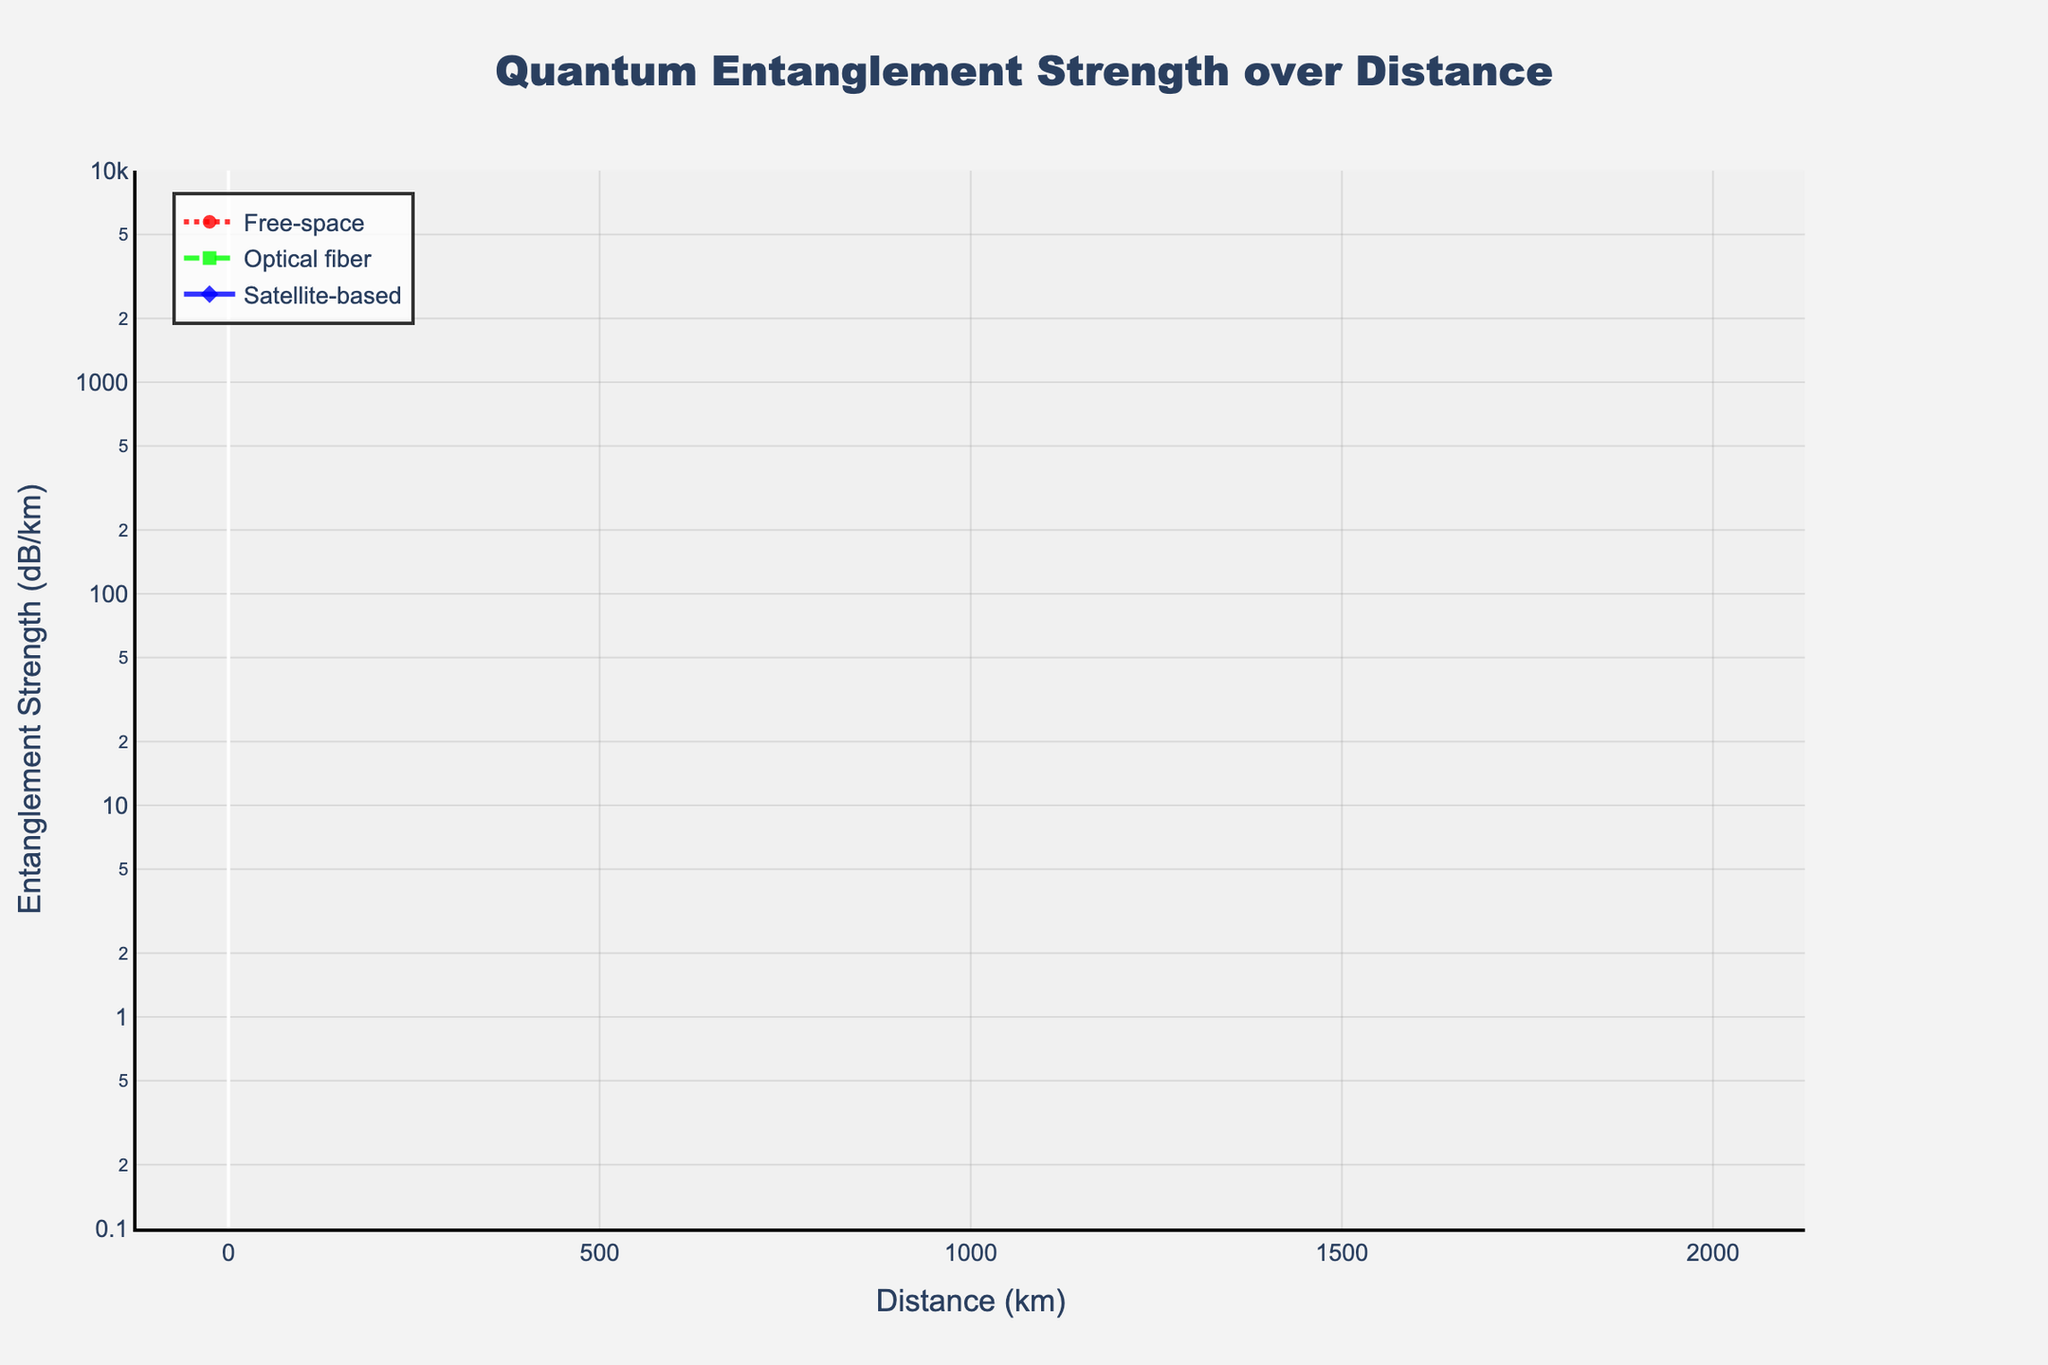What is the entanglement strength for free-space at 10 km? Look for the value corresponding to the "Free-space" line at 10 km on the x-axis. It is -2.0 dB/km.
Answer: -2.0 dB/km Compare the entanglement strength of optical fiber and satellite-based at 50 km. Which is stronger? Reference the values of "Optical fiber" and "Satellite-based" at 50 km on the x-axis. "Optical fiber" is at -25.0 dB/km and "Satellite-based" is at -5.0 dB/km. Satellite-based is stronger since -5.0 dB/km is higher than -25.0 dB/km.
Answer: Satellite-based Which technology has the steepest decline in entanglement strength at 250 km? Examine the slopes of the lines for each technology up to 250 km. "Optical fiber" drops from 0 to -125.0 dB/km, which is the steepest decline compared to others.
Answer: Optical fiber At what distance does free-space entanglement strength reach -50 dB/km? Locate the point on the "Free-space" line where the y-value is -50 dB/km. This corresponds to 250 km on the x-axis.
Answer: 250 km Calculate the average entanglement strength for satellite-based across all distances. Sum all satellite-based values (-0.1 - 0.5 - 1.0 - 2.5 - 5.0 - 10.0 - 25.0 - 50.0 - 75.0 - 100.0 - 150.0 - 200.0) and divide by the number of data points (13). This results in a total of -619.1 dB/km, so the average is -619.1/13 = -47.62 dB/km.
Answer: -47.62 dB/km How does the entanglement strength of free-space change over the range from 1 km to 5 km? Look at the "Free-space" values for 1 km and 5 km on the x-axis. It changes from -0.2 dB/km to -1.0 dB/km. The change is -1.0 - (-0.2) = -0.8 dB/km.
Answer: -0.8 dB/km What color represents the satellite-based entanglement strength in the figure? Identify the color of the line corresponding to "Satellite-based". It is blue.
Answer: Blue Between which two consecutive distance points does optical fiber show the greatest decrease in entanglement strength? Examine the "Optical fiber" line for the largest drop between consecutive points. The largest decrease, from -250.0 dB/km to -375.0 dB/km, occurs between 500 km and 750 km.
Answer: 500 km and 750 km 